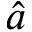<formula> <loc_0><loc_0><loc_500><loc_500>\hat { a }</formula> 